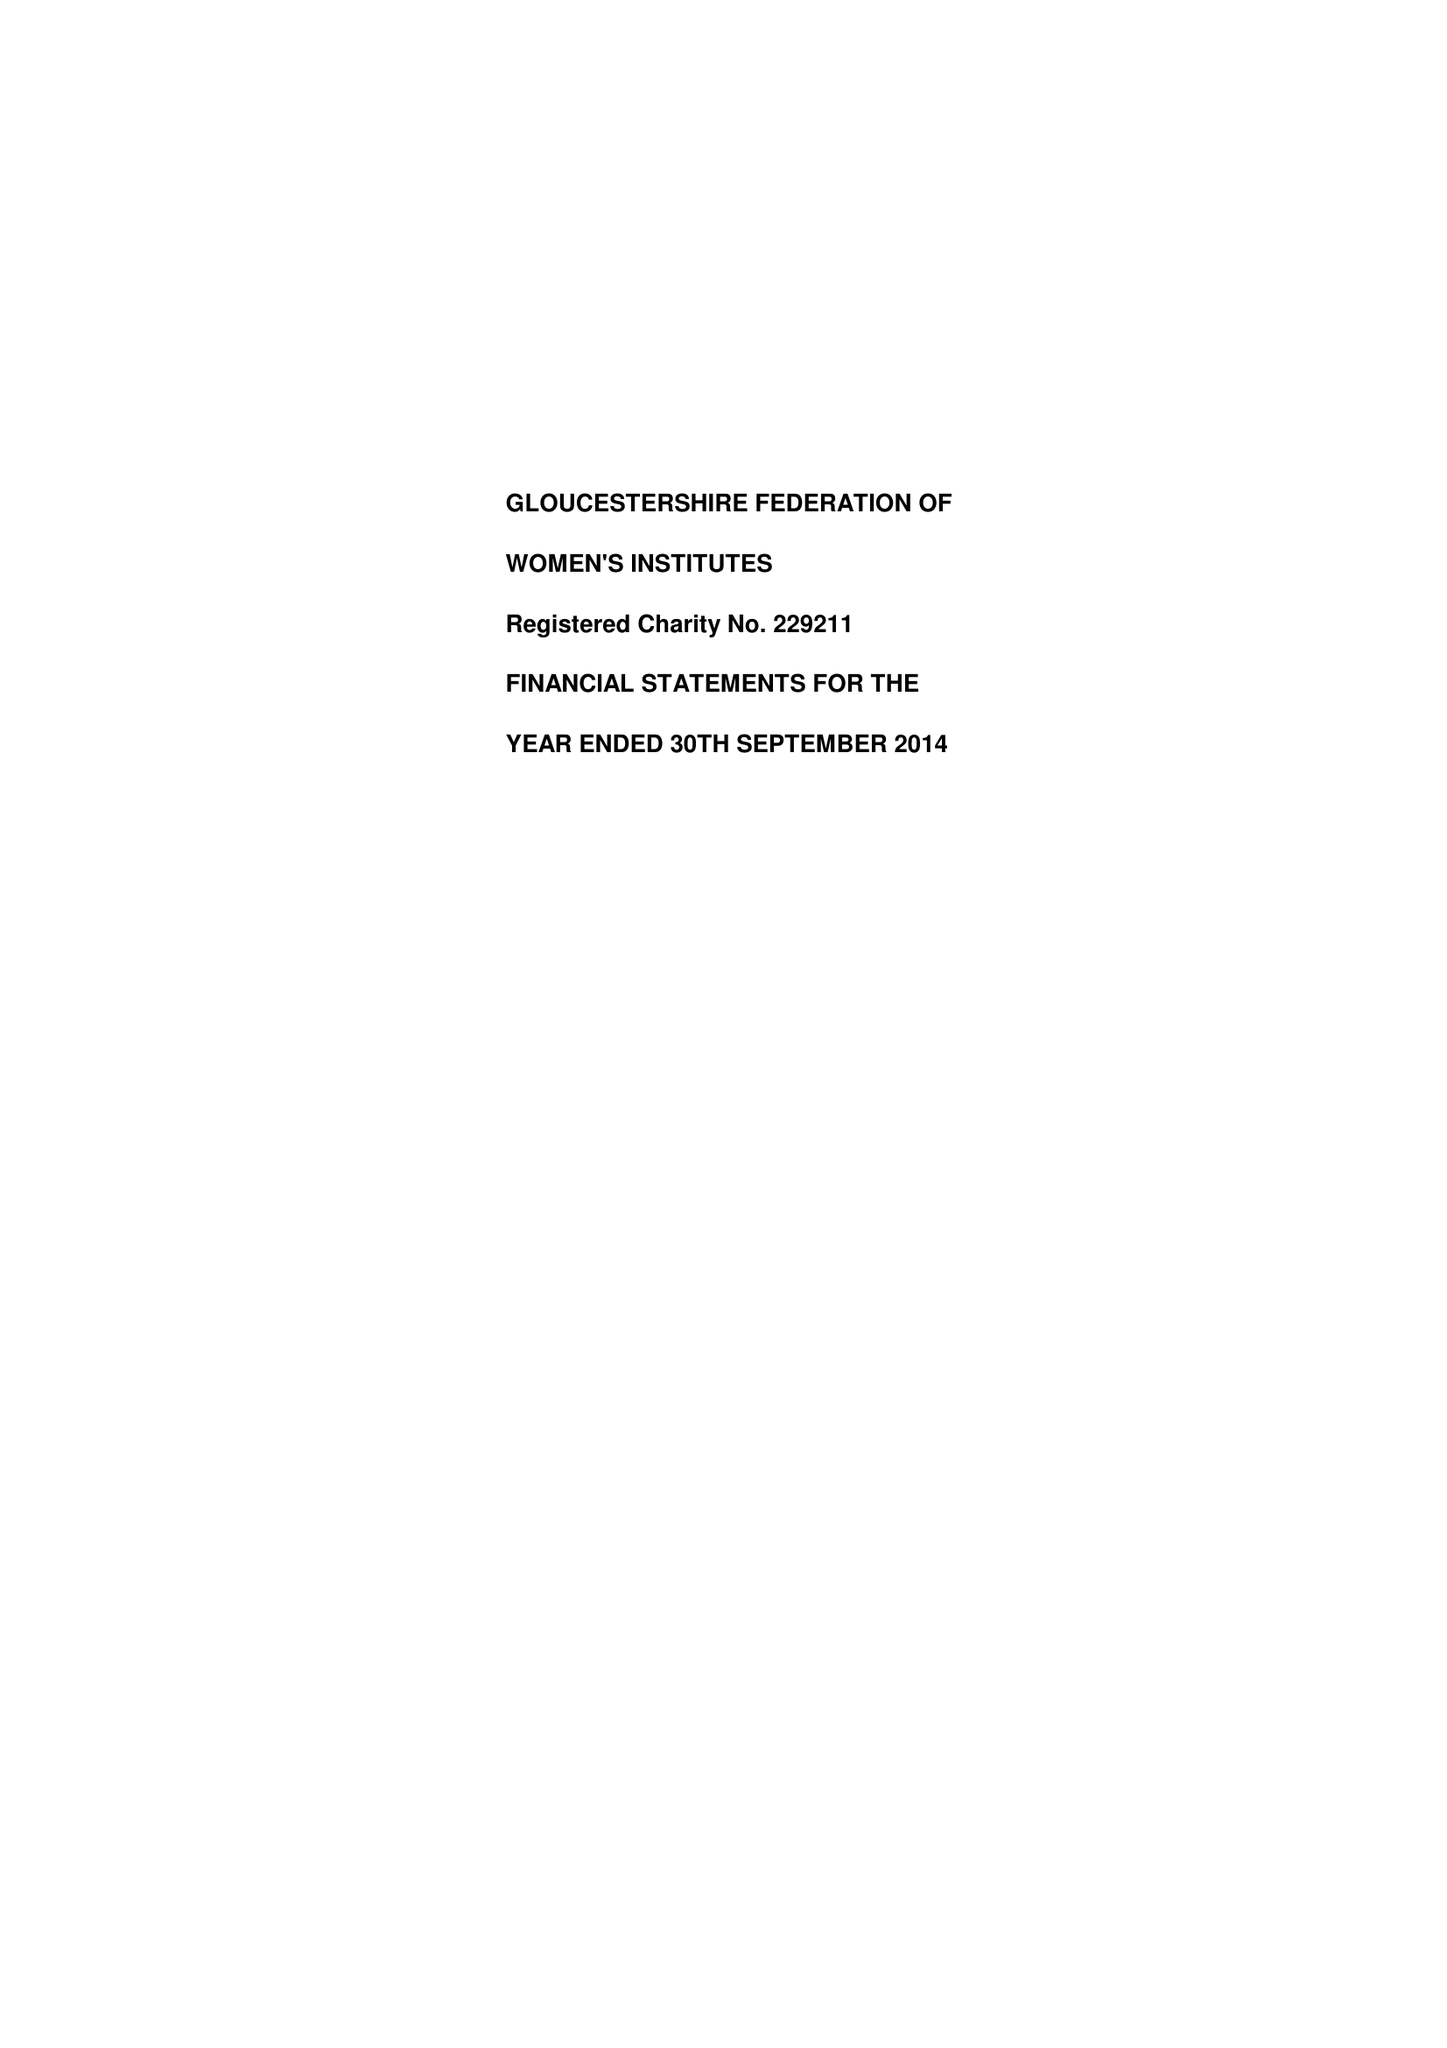What is the value for the spending_annually_in_british_pounds?
Answer the question using a single word or phrase. 215582.00 